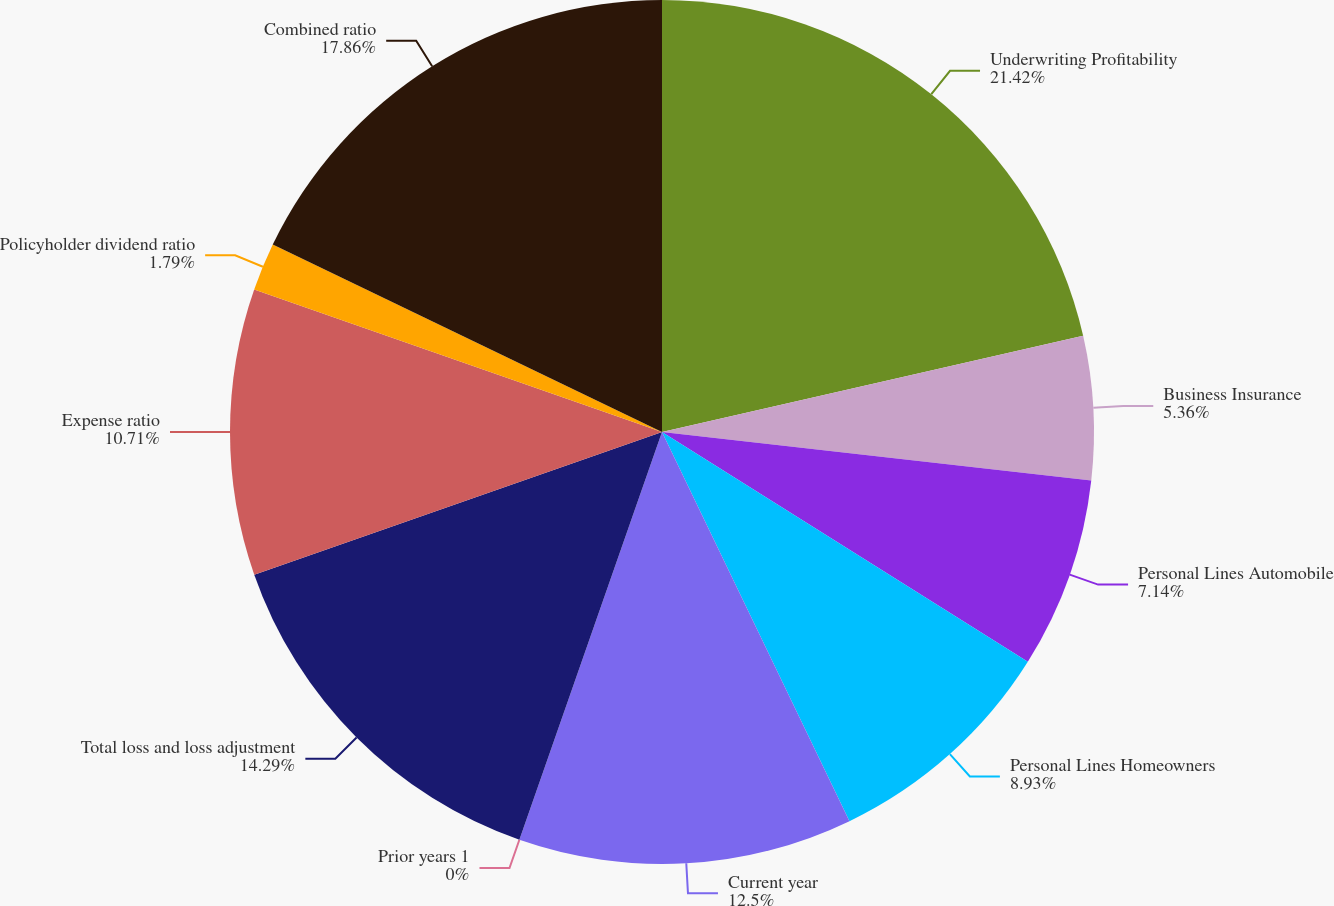Convert chart to OTSL. <chart><loc_0><loc_0><loc_500><loc_500><pie_chart><fcel>Underwriting Profitability<fcel>Business Insurance<fcel>Personal Lines Automobile<fcel>Personal Lines Homeowners<fcel>Current year<fcel>Prior years 1<fcel>Total loss and loss adjustment<fcel>Expense ratio<fcel>Policyholder dividend ratio<fcel>Combined ratio<nl><fcel>21.43%<fcel>5.36%<fcel>7.14%<fcel>8.93%<fcel>12.5%<fcel>0.0%<fcel>14.29%<fcel>10.71%<fcel>1.79%<fcel>17.86%<nl></chart> 